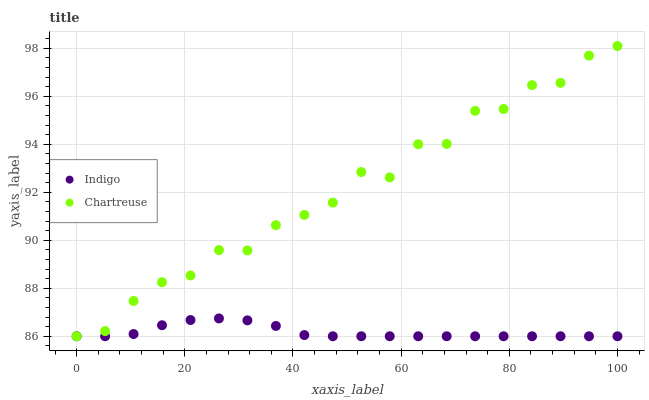Does Indigo have the minimum area under the curve?
Answer yes or no. Yes. Does Chartreuse have the maximum area under the curve?
Answer yes or no. Yes. Does Indigo have the maximum area under the curve?
Answer yes or no. No. Is Indigo the smoothest?
Answer yes or no. Yes. Is Chartreuse the roughest?
Answer yes or no. Yes. Is Indigo the roughest?
Answer yes or no. No. Does Chartreuse have the lowest value?
Answer yes or no. Yes. Does Chartreuse have the highest value?
Answer yes or no. Yes. Does Indigo have the highest value?
Answer yes or no. No. Does Chartreuse intersect Indigo?
Answer yes or no. Yes. Is Chartreuse less than Indigo?
Answer yes or no. No. Is Chartreuse greater than Indigo?
Answer yes or no. No. 